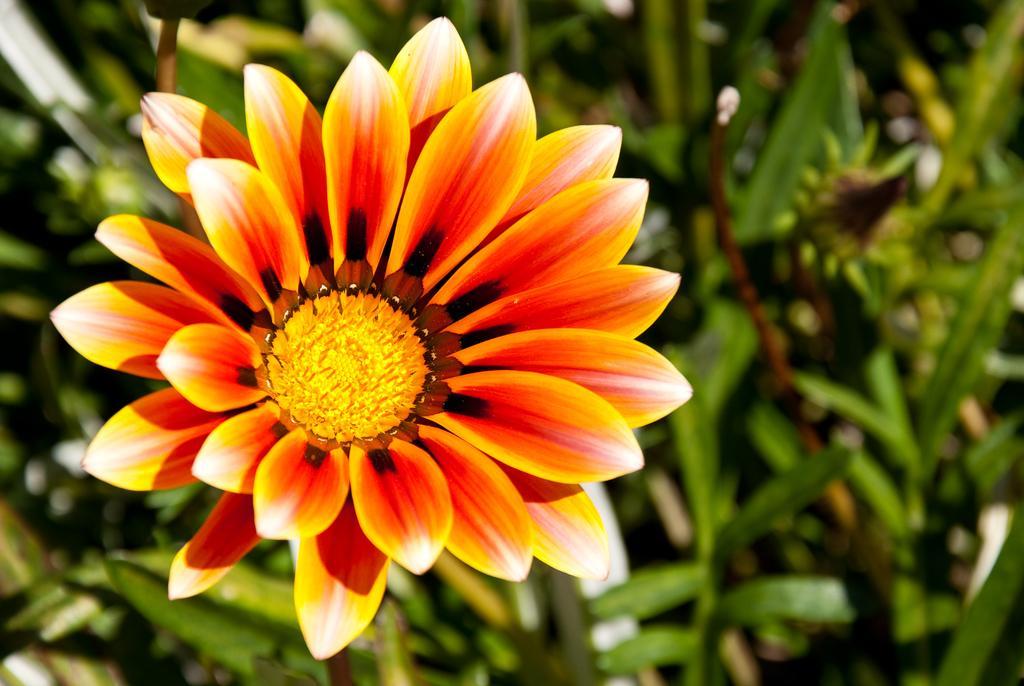Can you describe this image briefly? In the foreground of this picture we can see the flower. In the background we can see the green leaves and some objects of the plants. 